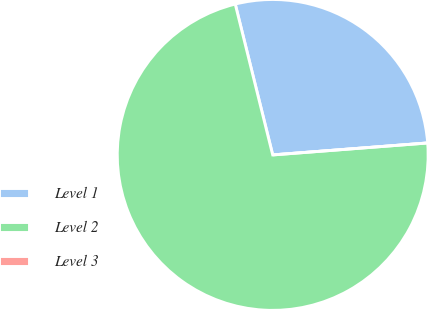Convert chart to OTSL. <chart><loc_0><loc_0><loc_500><loc_500><pie_chart><fcel>Level 1<fcel>Level 2<fcel>Level 3<nl><fcel>27.65%<fcel>72.35%<fcel>0.0%<nl></chart> 